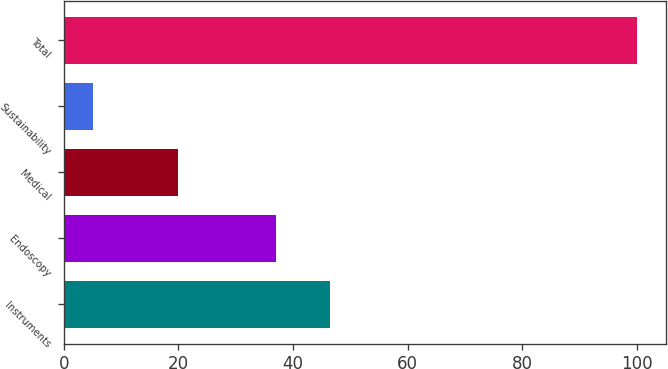Convert chart. <chart><loc_0><loc_0><loc_500><loc_500><bar_chart><fcel>Instruments<fcel>Endoscopy<fcel>Medical<fcel>Sustainability<fcel>Total<nl><fcel>46.5<fcel>37<fcel>20<fcel>5<fcel>100<nl></chart> 